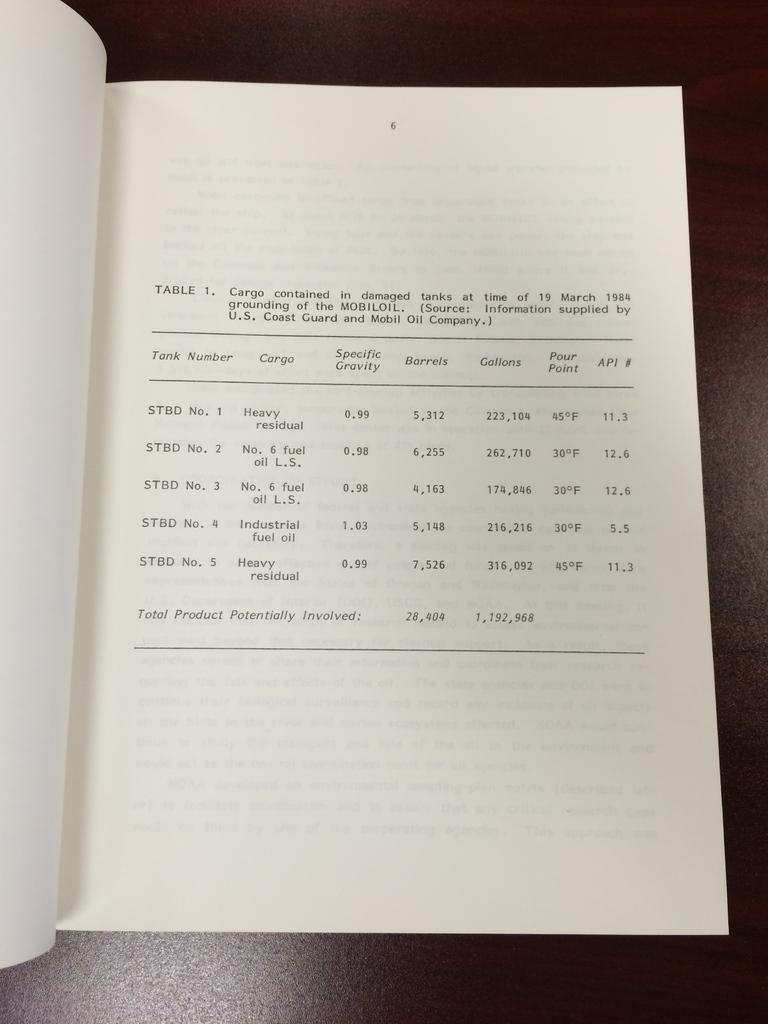What is the number of this table?
Provide a short and direct response. 1. 